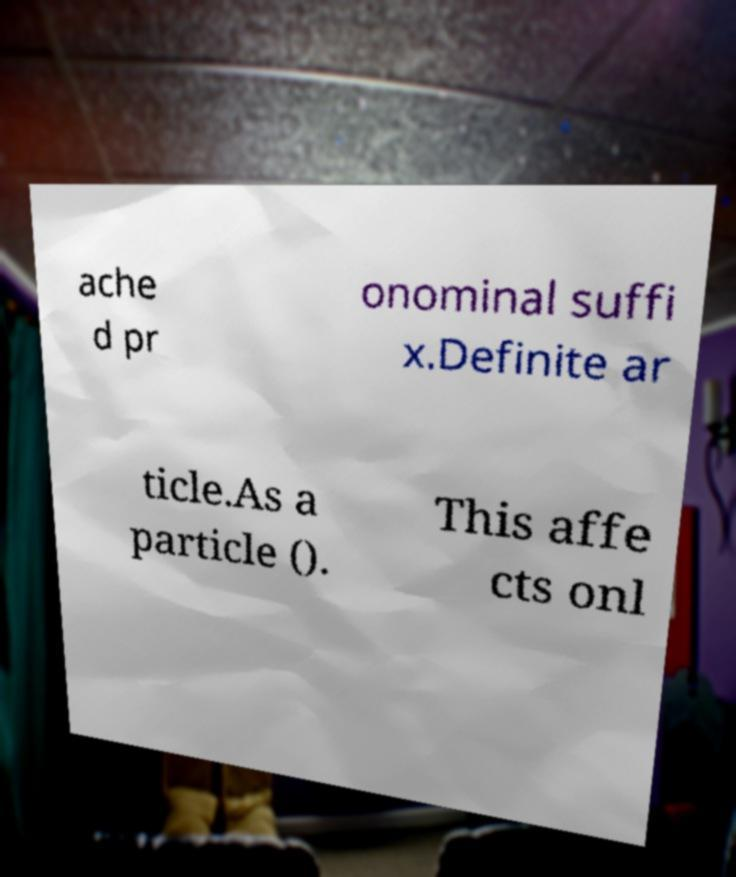Please read and relay the text visible in this image. What does it say? ache d pr onominal suffi x.Definite ar ticle.As a particle (). This affe cts onl 